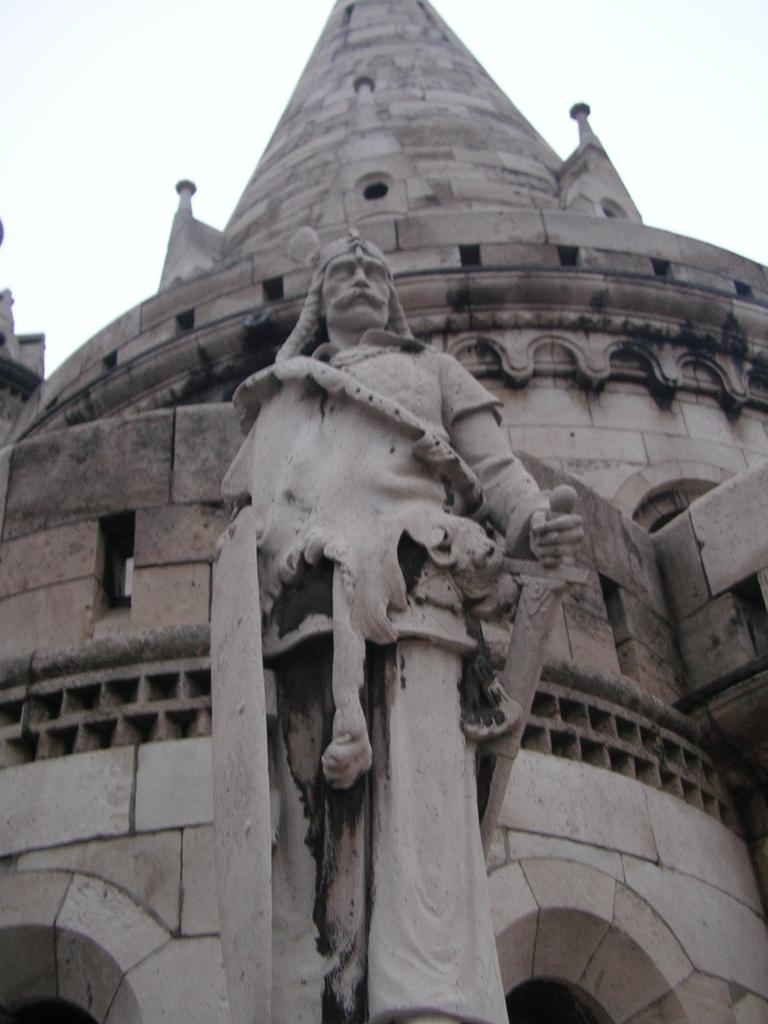What is the main subject of the image? There is a statue of a person in the image. Can you describe the color of the statue? The statue is ash in color. What can be seen in the background of the image? There is a building in the background of the image. What colors are used for the building? The building is ash and black in color. What is visible in the sky in the image? The sky is visible in the background of the image. How many trucks are parked near the statue in the image? There are no trucks present in the image; it features a statue and a building in the background. What type of bell can be heard ringing in the image? There is no bell present in the image, and therefore no sound can be heard. 